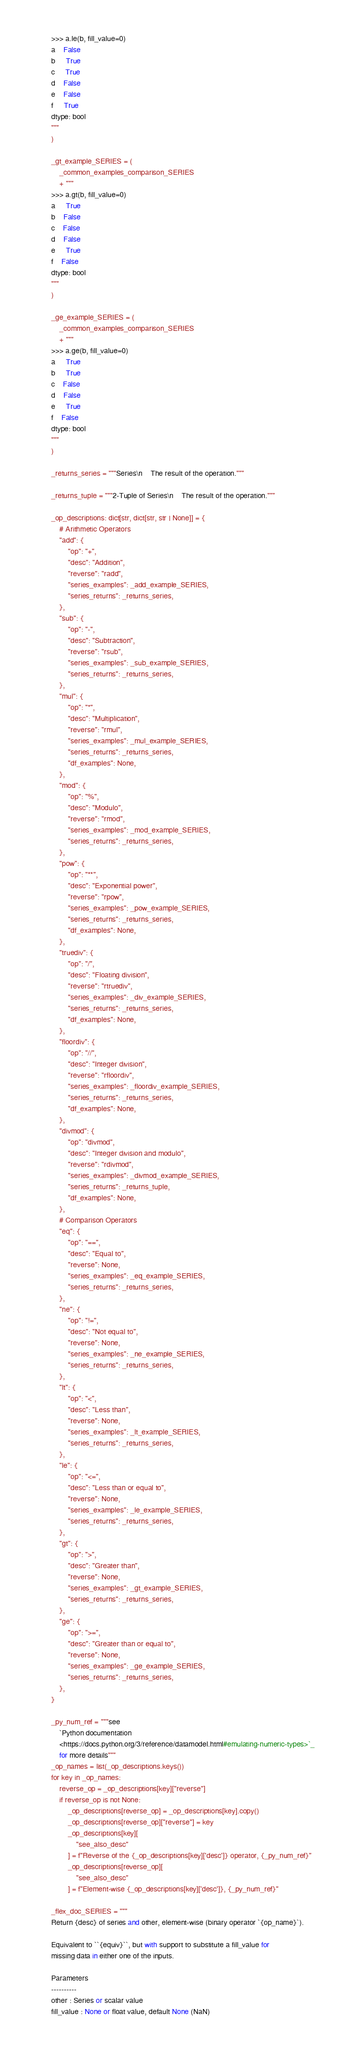Convert code to text. <code><loc_0><loc_0><loc_500><loc_500><_Python_>>>> a.le(b, fill_value=0)
a    False
b     True
c     True
d    False
e    False
f     True
dtype: bool
"""
)

_gt_example_SERIES = (
    _common_examples_comparison_SERIES
    + """
>>> a.gt(b, fill_value=0)
a     True
b    False
c    False
d    False
e     True
f    False
dtype: bool
"""
)

_ge_example_SERIES = (
    _common_examples_comparison_SERIES
    + """
>>> a.ge(b, fill_value=0)
a     True
b     True
c    False
d    False
e     True
f    False
dtype: bool
"""
)

_returns_series = """Series\n    The result of the operation."""

_returns_tuple = """2-Tuple of Series\n    The result of the operation."""

_op_descriptions: dict[str, dict[str, str | None]] = {
    # Arithmetic Operators
    "add": {
        "op": "+",
        "desc": "Addition",
        "reverse": "radd",
        "series_examples": _add_example_SERIES,
        "series_returns": _returns_series,
    },
    "sub": {
        "op": "-",
        "desc": "Subtraction",
        "reverse": "rsub",
        "series_examples": _sub_example_SERIES,
        "series_returns": _returns_series,
    },
    "mul": {
        "op": "*",
        "desc": "Multiplication",
        "reverse": "rmul",
        "series_examples": _mul_example_SERIES,
        "series_returns": _returns_series,
        "df_examples": None,
    },
    "mod": {
        "op": "%",
        "desc": "Modulo",
        "reverse": "rmod",
        "series_examples": _mod_example_SERIES,
        "series_returns": _returns_series,
    },
    "pow": {
        "op": "**",
        "desc": "Exponential power",
        "reverse": "rpow",
        "series_examples": _pow_example_SERIES,
        "series_returns": _returns_series,
        "df_examples": None,
    },
    "truediv": {
        "op": "/",
        "desc": "Floating division",
        "reverse": "rtruediv",
        "series_examples": _div_example_SERIES,
        "series_returns": _returns_series,
        "df_examples": None,
    },
    "floordiv": {
        "op": "//",
        "desc": "Integer division",
        "reverse": "rfloordiv",
        "series_examples": _floordiv_example_SERIES,
        "series_returns": _returns_series,
        "df_examples": None,
    },
    "divmod": {
        "op": "divmod",
        "desc": "Integer division and modulo",
        "reverse": "rdivmod",
        "series_examples": _divmod_example_SERIES,
        "series_returns": _returns_tuple,
        "df_examples": None,
    },
    # Comparison Operators
    "eq": {
        "op": "==",
        "desc": "Equal to",
        "reverse": None,
        "series_examples": _eq_example_SERIES,
        "series_returns": _returns_series,
    },
    "ne": {
        "op": "!=",
        "desc": "Not equal to",
        "reverse": None,
        "series_examples": _ne_example_SERIES,
        "series_returns": _returns_series,
    },
    "lt": {
        "op": "<",
        "desc": "Less than",
        "reverse": None,
        "series_examples": _lt_example_SERIES,
        "series_returns": _returns_series,
    },
    "le": {
        "op": "<=",
        "desc": "Less than or equal to",
        "reverse": None,
        "series_examples": _le_example_SERIES,
        "series_returns": _returns_series,
    },
    "gt": {
        "op": ">",
        "desc": "Greater than",
        "reverse": None,
        "series_examples": _gt_example_SERIES,
        "series_returns": _returns_series,
    },
    "ge": {
        "op": ">=",
        "desc": "Greater than or equal to",
        "reverse": None,
        "series_examples": _ge_example_SERIES,
        "series_returns": _returns_series,
    },
}

_py_num_ref = """see
    `Python documentation
    <https://docs.python.org/3/reference/datamodel.html#emulating-numeric-types>`_
    for more details"""
_op_names = list(_op_descriptions.keys())
for key in _op_names:
    reverse_op = _op_descriptions[key]["reverse"]
    if reverse_op is not None:
        _op_descriptions[reverse_op] = _op_descriptions[key].copy()
        _op_descriptions[reverse_op]["reverse"] = key
        _op_descriptions[key][
            "see_also_desc"
        ] = f"Reverse of the {_op_descriptions[key]['desc']} operator, {_py_num_ref}"
        _op_descriptions[reverse_op][
            "see_also_desc"
        ] = f"Element-wise {_op_descriptions[key]['desc']}, {_py_num_ref}"

_flex_doc_SERIES = """
Return {desc} of series and other, element-wise (binary operator `{op_name}`).

Equivalent to ``{equiv}``, but with support to substitute a fill_value for
missing data in either one of the inputs.

Parameters
----------
other : Series or scalar value
fill_value : None or float value, default None (NaN)</code> 